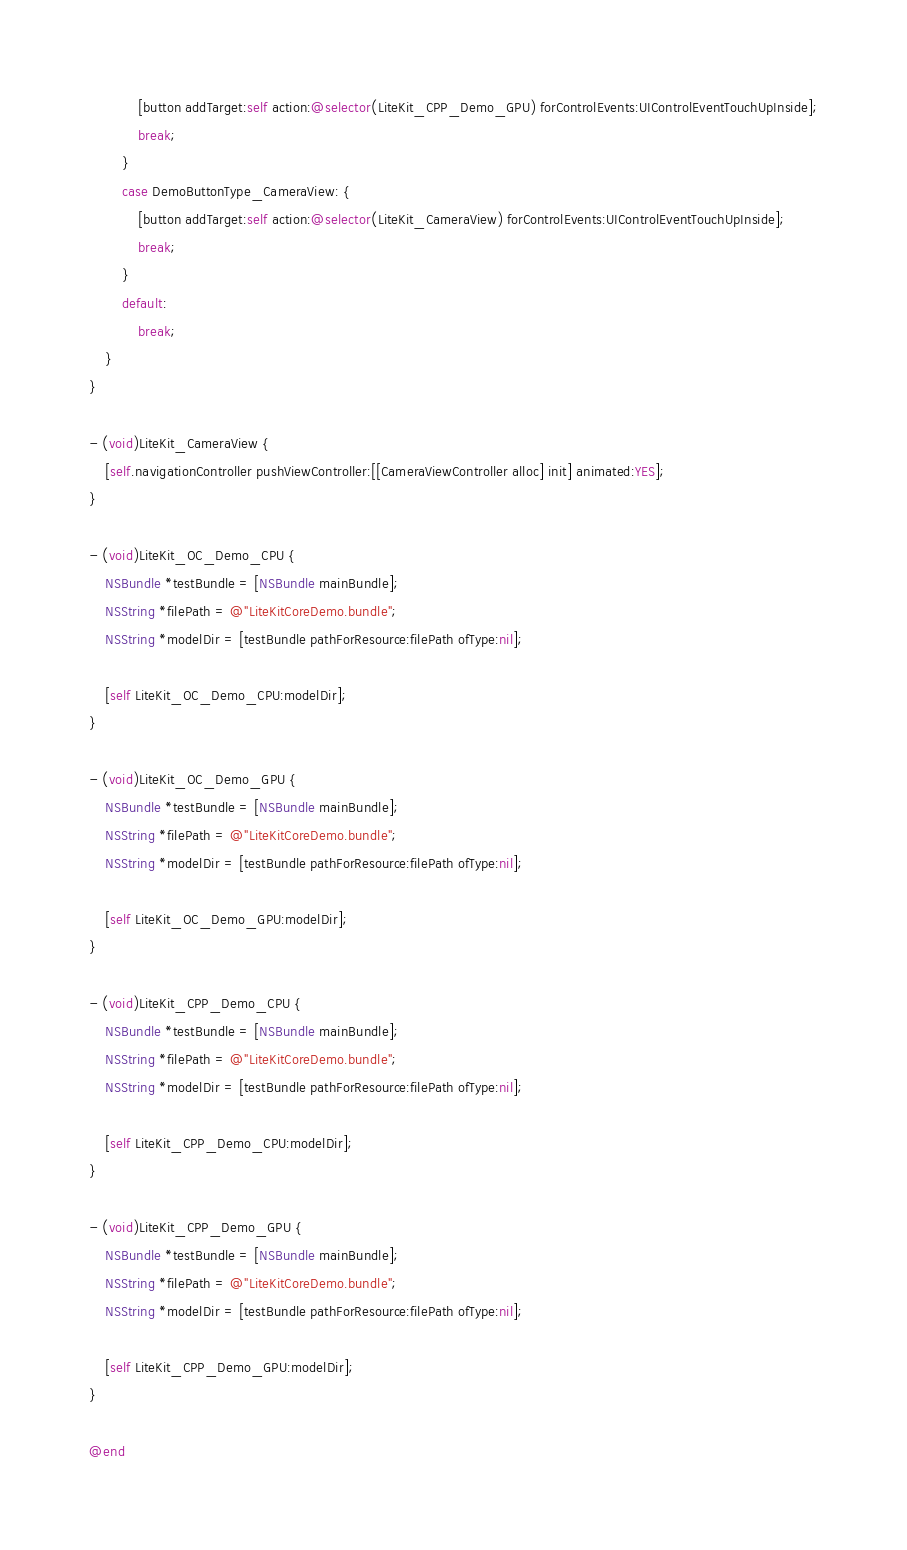Convert code to text. <code><loc_0><loc_0><loc_500><loc_500><_ObjectiveC_>            [button addTarget:self action:@selector(LiteKit_CPP_Demo_GPU) forControlEvents:UIControlEventTouchUpInside];
            break;
        }
        case DemoButtonType_CameraView: {
            [button addTarget:self action:@selector(LiteKit_CameraView) forControlEvents:UIControlEventTouchUpInside];
            break;
        }
        default:
            break;
    }
}

- (void)LiteKit_CameraView {
    [self.navigationController pushViewController:[[CameraViewController alloc] init] animated:YES];
}

- (void)LiteKit_OC_Demo_CPU {
    NSBundle *testBundle = [NSBundle mainBundle];
    NSString *filePath = @"LiteKitCoreDemo.bundle";
    NSString *modelDir = [testBundle pathForResource:filePath ofType:nil];
    
    [self LiteKit_OC_Demo_CPU:modelDir];
}

- (void)LiteKit_OC_Demo_GPU {
    NSBundle *testBundle = [NSBundle mainBundle];
    NSString *filePath = @"LiteKitCoreDemo.bundle";
    NSString *modelDir = [testBundle pathForResource:filePath ofType:nil];
    
    [self LiteKit_OC_Demo_GPU:modelDir];
}

- (void)LiteKit_CPP_Demo_CPU {
    NSBundle *testBundle = [NSBundle mainBundle];
    NSString *filePath = @"LiteKitCoreDemo.bundle";
    NSString *modelDir = [testBundle pathForResource:filePath ofType:nil];
    
    [self LiteKit_CPP_Demo_CPU:modelDir];
}

- (void)LiteKit_CPP_Demo_GPU {
    NSBundle *testBundle = [NSBundle mainBundle];
    NSString *filePath = @"LiteKitCoreDemo.bundle";
    NSString *modelDir = [testBundle pathForResource:filePath ofType:nil];
    
    [self LiteKit_CPP_Demo_GPU:modelDir];
}

@end
</code> 